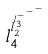<formula> <loc_0><loc_0><loc_500><loc_500>l _ { 4 } ^ { l _ { 2 } ^ { l _ { 3 } ^ { - ^ { - ^ { - } } } } }</formula> 